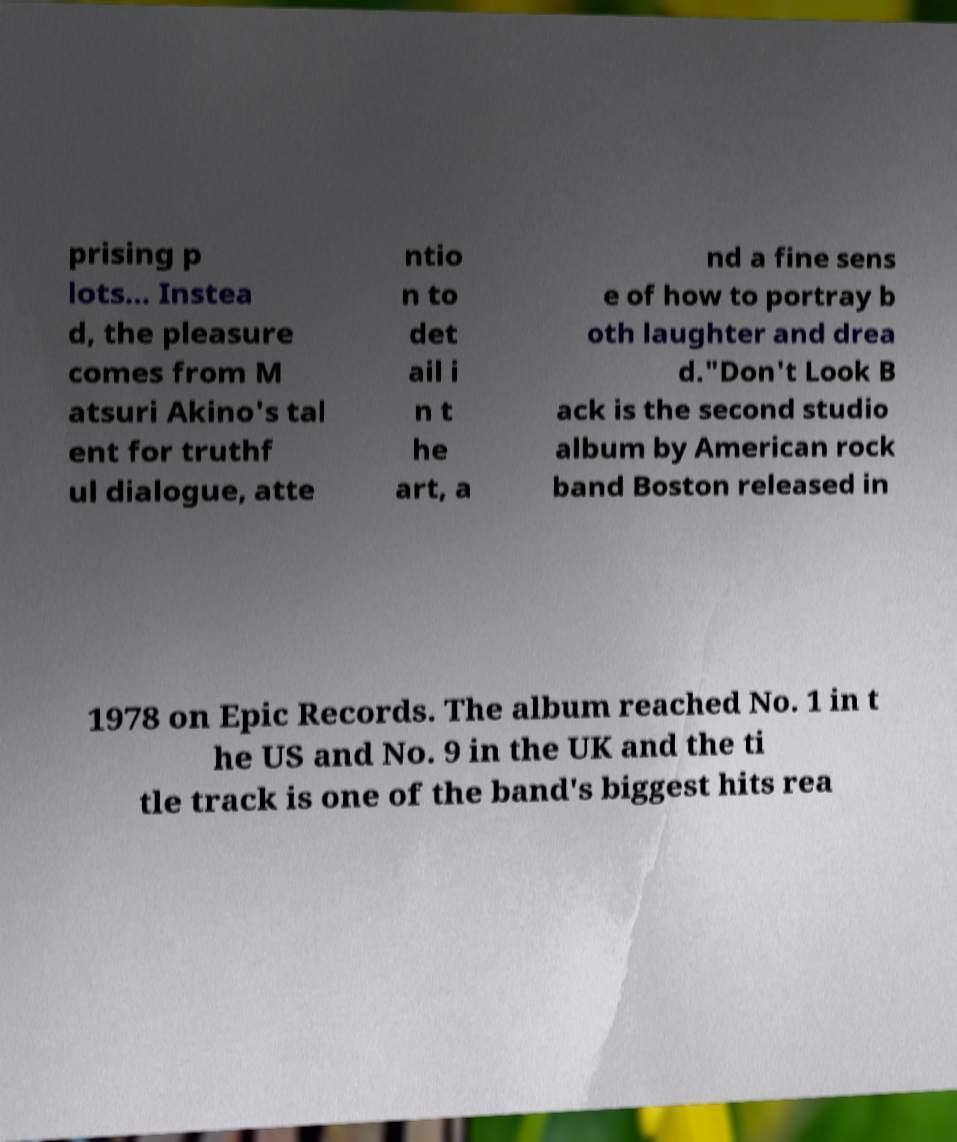Could you extract and type out the text from this image? prising p lots... Instea d, the pleasure comes from M atsuri Akino's tal ent for truthf ul dialogue, atte ntio n to det ail i n t he art, a nd a fine sens e of how to portray b oth laughter and drea d."Don't Look B ack is the second studio album by American rock band Boston released in 1978 on Epic Records. The album reached No. 1 in t he US and No. 9 in the UK and the ti tle track is one of the band's biggest hits rea 